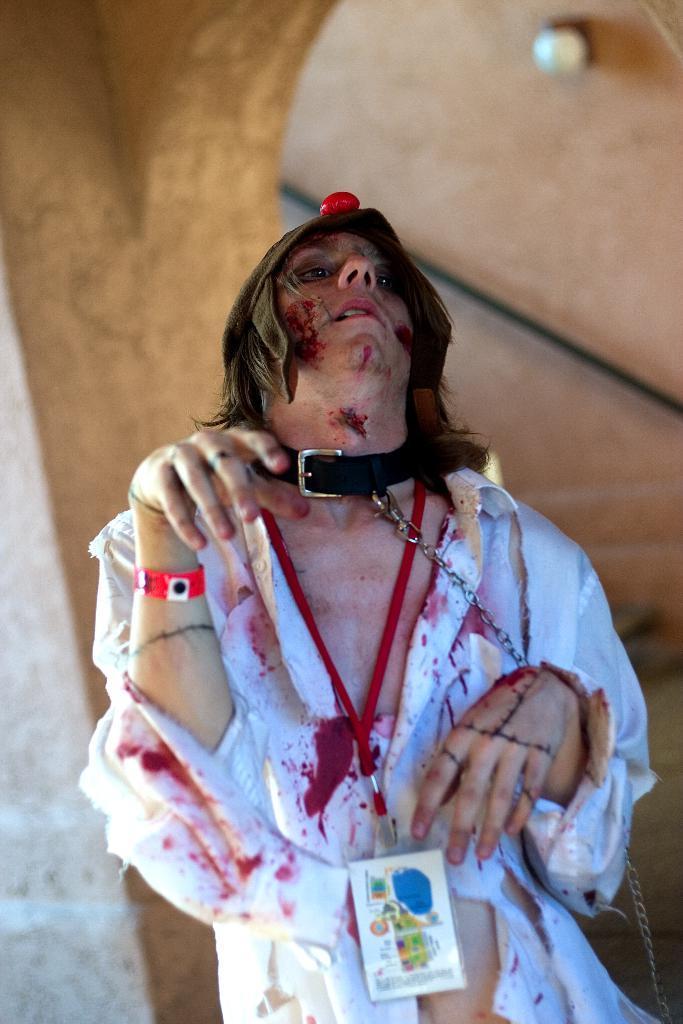Describe this image in one or two sentences. In the center of the image we can see a cosplay. In the background there is a wall. 